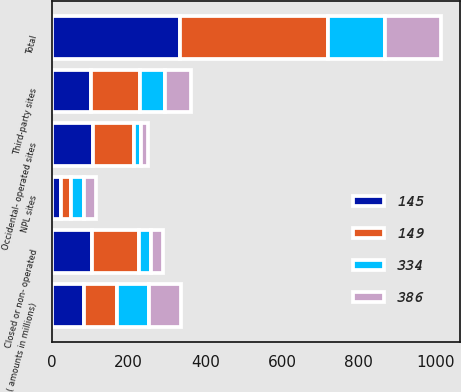Convert chart. <chart><loc_0><loc_0><loc_500><loc_500><stacked_bar_chart><ecel><fcel>( amounts in millions)<fcel>NPL sites<fcel>Third-party sites<fcel>Occidental- operated sites<fcel>Closed or non- operated<fcel>Total<nl><fcel>334<fcel>84<fcel>34<fcel>66<fcel>18<fcel>31<fcel>149<nl><fcel>149<fcel>84<fcel>27<fcel>128<fcel>107<fcel>124<fcel>386<nl><fcel>386<fcel>84<fcel>30<fcel>67<fcel>17<fcel>31<fcel>145<nl><fcel>145<fcel>84<fcel>23<fcel>101<fcel>107<fcel>103<fcel>334<nl></chart> 